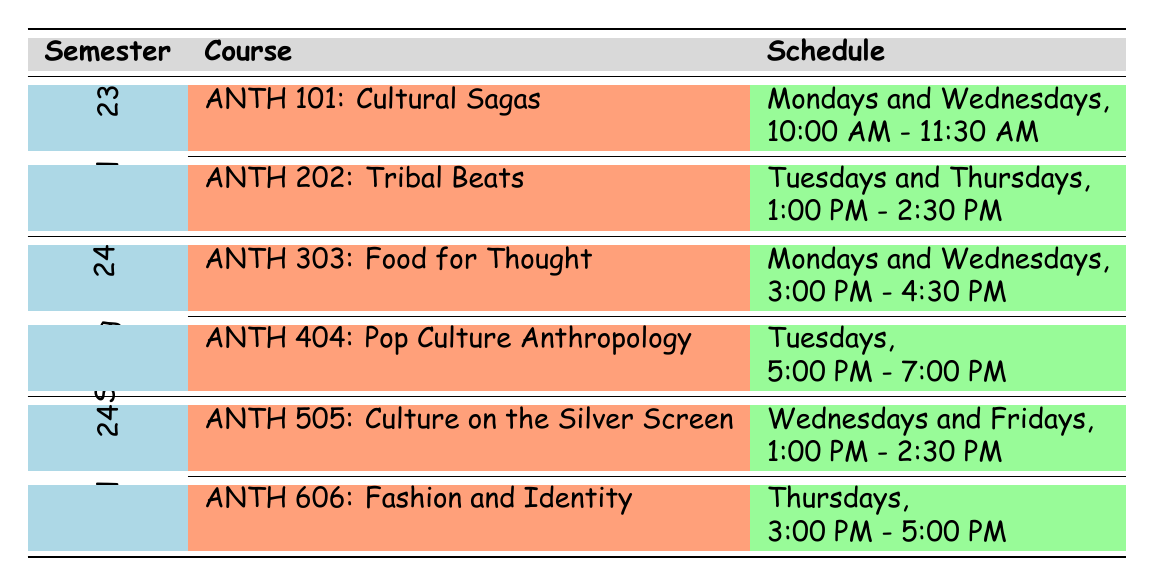What are the course titles offered in Fall 2023? The table lists two courses for Fall 2023: ANTH 101 titled "Cultural Sagas: Storytelling in Societies" and ANTH 202 titled "Tribal Beats: Music and Identity."
Answer: Cultural Sagas: Storytelling in Societies, Tribal Beats: Music and Identity Which course is taught by Prof. Chic A. Roo? The table shows that ANTH 606 titled "Fashion and Identity: Threads of Culture" is taught by Prof. Chic A. Roo.
Answer: ANTH 606: Fashion and Identity: Threads of Culture How many courses are offered in Spring 2024? The table indicates that there are two courses for Spring 2024: ANTH 303 and ANTH 404, so the total number of courses is 2.
Answer: 2 Is Dr. Loretta Fables teaching a course in Fall 2024? In the table, there are no courses associated with Dr. Loretta Fables in Fall 2024; she teaches in Fall 2023 only.
Answer: No What is the schedule for ANTH 404: Pop Culture Anthropology? The table shows that ANTH 404 is scheduled for Tuesdays from 5:00 PM to 7:00 PM.
Answer: Tuesdays, 5:00 PM - 7:00 PM Which course has the latest start time during the themed semesters? By examining the schedules, ANTH 404: Pop Culture Anthropology starts at 5:00 PM, which is later than any other course listed.
Answer: ANTH 404: Pop Culture Anthropology How many different instructors are teaching during the Fall 2023 semester? The table indicates that there are two different instructors for the Fall 2023 semester: Dr. Loretta Fables and Prof. Melody Vibe. Hence, the count is 2.
Answer: 2 In which semester is "Culture on the Silver Screen" offered, and who is the instructor? "Culture on the Silver Screen" is offered in Fall 2024 and is taught by Dr. Cinema Hilaris, as per the table.
Answer: Fall 2024, Dr. Cinema Hilaris Which course in Spring 2024 has a focus on food and cooking traditions? The table reveals that ANTH 303 titled "Food for Thought: Culinary Cultures" focuses on food and cooking traditions in Spring 2024.
Answer: ANTH 303: Food for Thought: Culinary Cultures 